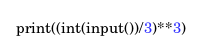Convert code to text. <code><loc_0><loc_0><loc_500><loc_500><_Python_>print((int(input())/3)**3)</code> 